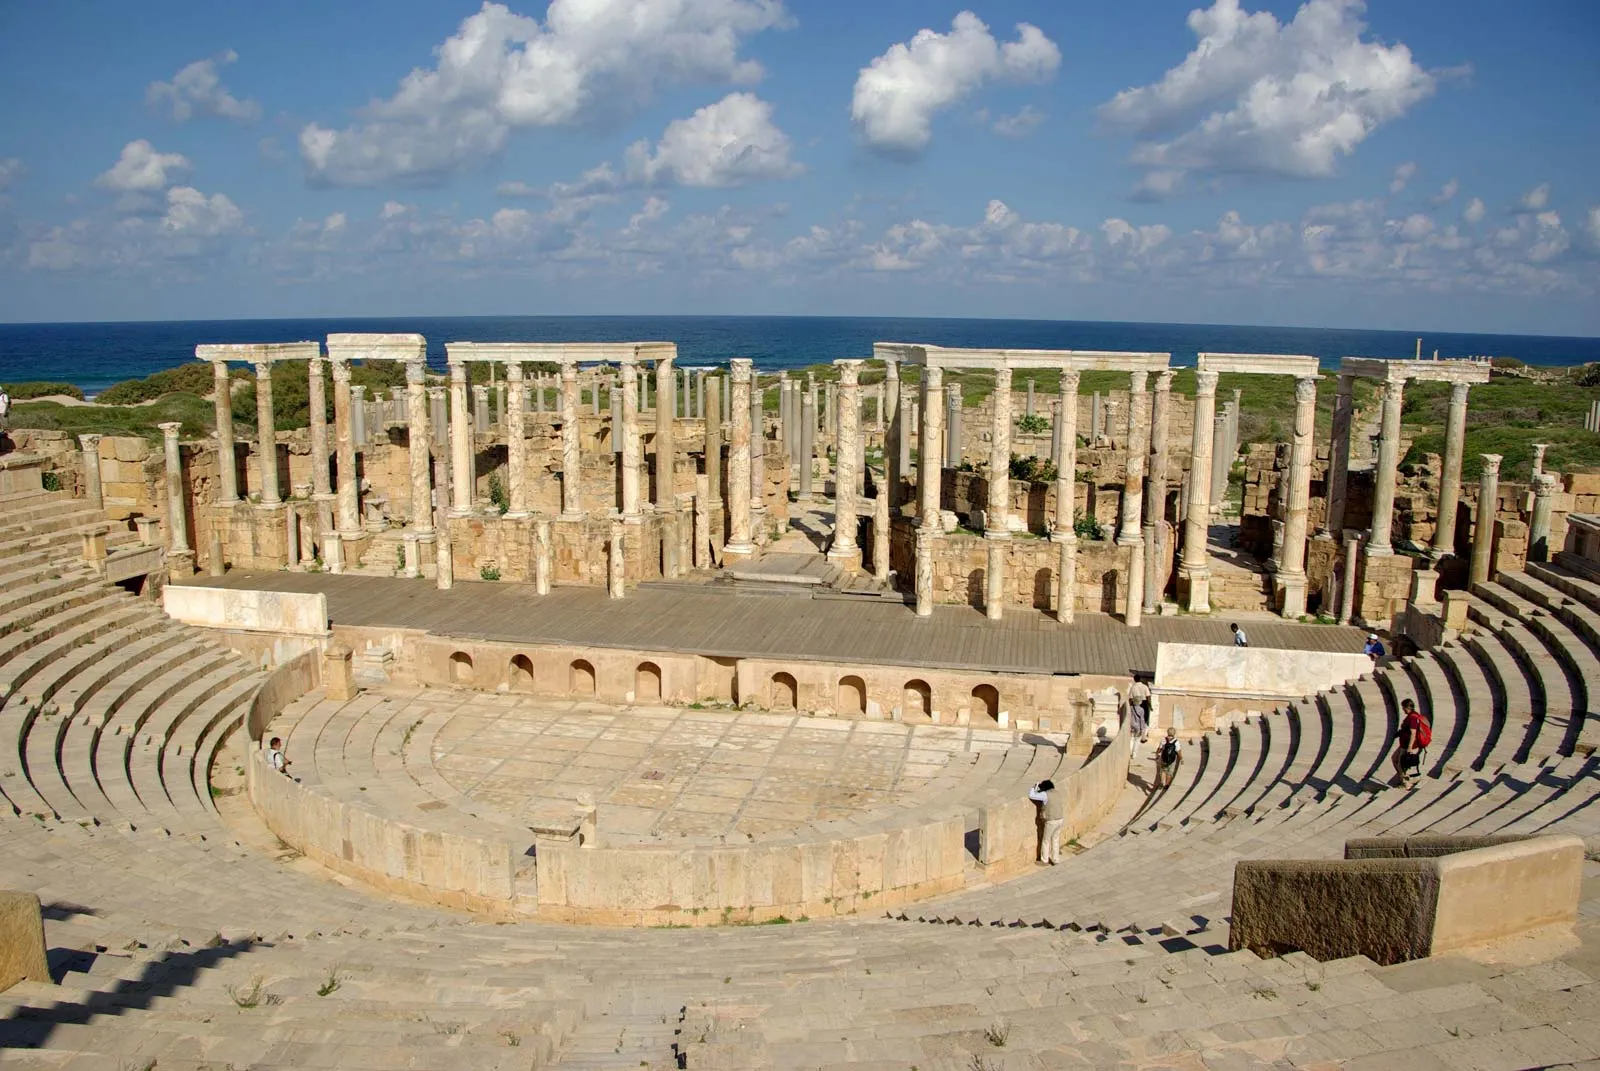Describe a rediscovery moment of this site after centuries during a modern archeological excavation. During a modern archaeological excavation, a rediscovery moment at Leptis Magna after centuries would be profoundly exhilarating. As the archaeologists meticulously brush away layers of soil and debris, the first sight of the well-preserved stone structures would spark immense excitement. They'd uncover the amphitheater's grand seating, the columns, and intricate stonework, revealing details that have been hidden for ages. The air would be thick with awe and reverence as the ancient craftsmanship is revealed, each artifact providing a tangible connection to the people who once walked these grounds. The team would document their findings with cutting-edge technology, ensuring every relic and piece of architecture is preserved and understood. This rediscovery would reignite interest in Roman history, emphasizing the site's historical significance and sparking a renewed commitment to its preservation and study for future generations. 